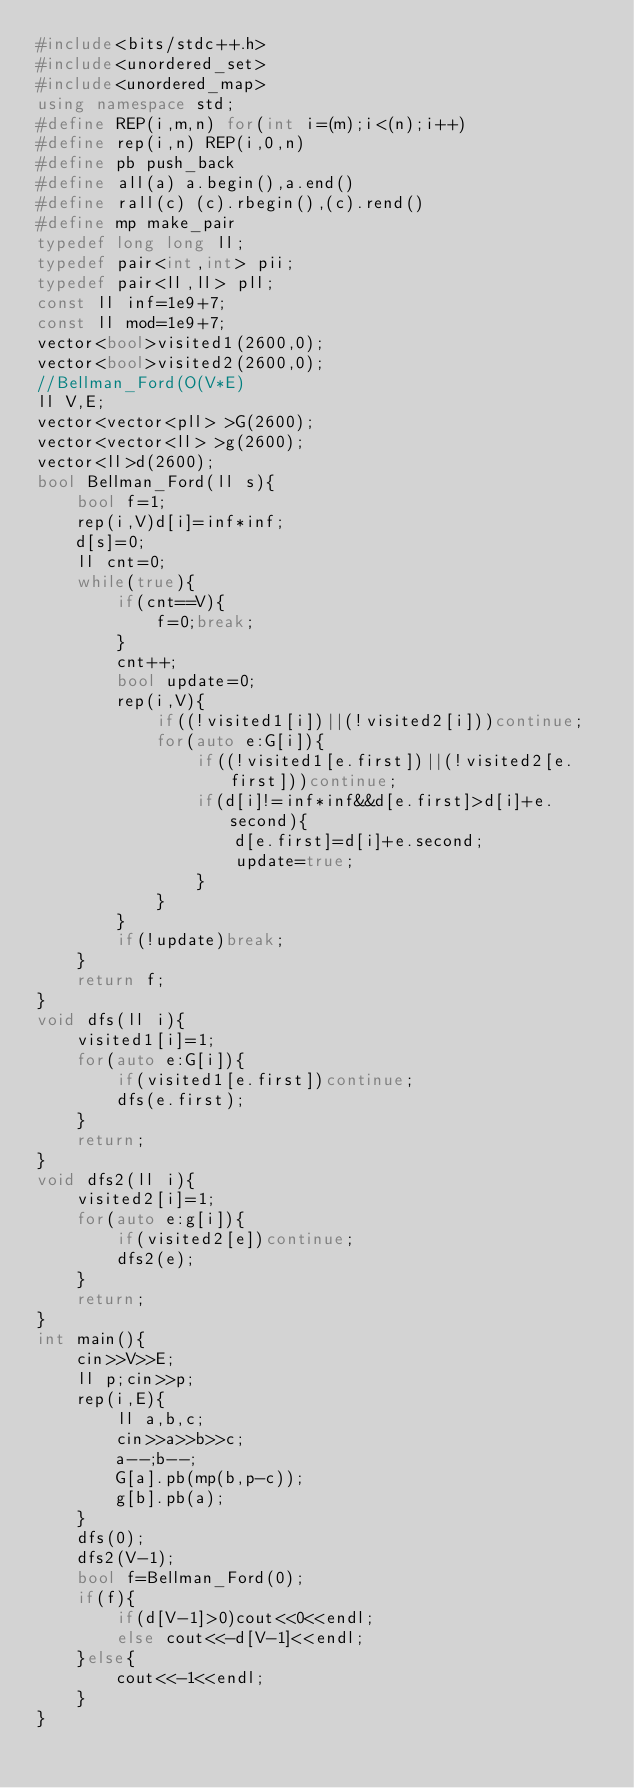<code> <loc_0><loc_0><loc_500><loc_500><_C++_>#include<bits/stdc++.h>
#include<unordered_set>
#include<unordered_map>
using namespace std;
#define REP(i,m,n) for(int i=(m);i<(n);i++)
#define rep(i,n) REP(i,0,n)
#define pb push_back
#define all(a) a.begin(),a.end()
#define rall(c) (c).rbegin(),(c).rend()
#define mp make_pair
typedef long long ll;
typedef pair<int,int> pii;
typedef pair<ll,ll> pll;
const ll inf=1e9+7;
const ll mod=1e9+7;
vector<bool>visited1(2600,0);
vector<bool>visited2(2600,0);
//Bellman_Ford(O(V*E)
ll V,E;
vector<vector<pll> >G(2600);
vector<vector<ll> >g(2600);
vector<ll>d(2600);
bool Bellman_Ford(ll s){
    bool f=1;
    rep(i,V)d[i]=inf*inf;
    d[s]=0;
    ll cnt=0;
    while(true){
        if(cnt==V){
            f=0;break;
        }
        cnt++;
        bool update=0;
        rep(i,V){
            if((!visited1[i])||(!visited2[i]))continue;
            for(auto e:G[i]){
                if((!visited1[e.first])||(!visited2[e.first]))continue;
                if(d[i]!=inf*inf&&d[e.first]>d[i]+e.second){
                    d[e.first]=d[i]+e.second;
                    update=true;
                }
            }
        }
        if(!update)break;
    }
    return f;
}
void dfs(ll i){
    visited1[i]=1;
    for(auto e:G[i]){
        if(visited1[e.first])continue;
        dfs(e.first);
    }
    return;
}
void dfs2(ll i){
    visited2[i]=1;
    for(auto e:g[i]){
        if(visited2[e])continue;
        dfs2(e);
    }
    return;
}
int main(){
    cin>>V>>E;
    ll p;cin>>p;
    rep(i,E){
        ll a,b,c;
        cin>>a>>b>>c;
        a--;b--;
        G[a].pb(mp(b,p-c));
        g[b].pb(a);
    }
    dfs(0);
    dfs2(V-1);
    bool f=Bellman_Ford(0);
    if(f){
        if(d[V-1]>0)cout<<0<<endl;
        else cout<<-d[V-1]<<endl;
    }else{
        cout<<-1<<endl;
    }
}</code> 